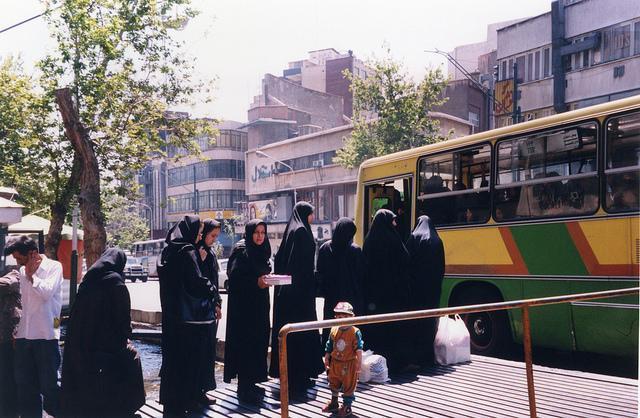How many people are in the picture?
Give a very brief answer. 9. 